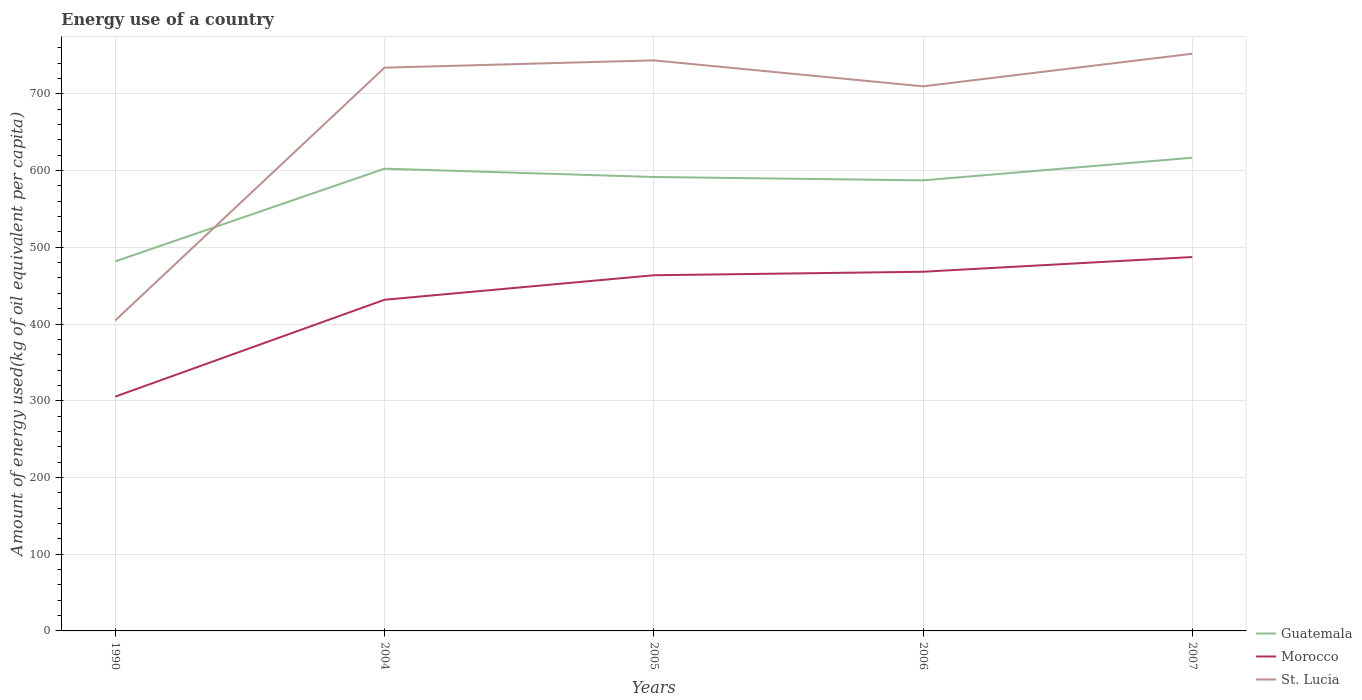How many different coloured lines are there?
Give a very brief answer. 3. Across all years, what is the maximum amount of energy used in in St. Lucia?
Your answer should be very brief. 404.69. In which year was the amount of energy used in in St. Lucia maximum?
Provide a short and direct response. 1990. What is the total amount of energy used in in Morocco in the graph?
Keep it short and to the point. -23.75. What is the difference between the highest and the second highest amount of energy used in in Morocco?
Offer a very short reply. 181.91. What is the difference between the highest and the lowest amount of energy used in in Morocco?
Your answer should be compact. 4. How many years are there in the graph?
Ensure brevity in your answer.  5. What is the difference between two consecutive major ticks on the Y-axis?
Your answer should be compact. 100. Does the graph contain any zero values?
Your answer should be very brief. No. What is the title of the graph?
Keep it short and to the point. Energy use of a country. Does "North America" appear as one of the legend labels in the graph?
Your answer should be compact. No. What is the label or title of the Y-axis?
Offer a terse response. Amount of energy used(kg of oil equivalent per capita). What is the Amount of energy used(kg of oil equivalent per capita) of Guatemala in 1990?
Your response must be concise. 481.64. What is the Amount of energy used(kg of oil equivalent per capita) of Morocco in 1990?
Provide a short and direct response. 305.39. What is the Amount of energy used(kg of oil equivalent per capita) of St. Lucia in 1990?
Your answer should be very brief. 404.69. What is the Amount of energy used(kg of oil equivalent per capita) in Guatemala in 2004?
Offer a very short reply. 602.44. What is the Amount of energy used(kg of oil equivalent per capita) of Morocco in 2004?
Ensure brevity in your answer.  431.63. What is the Amount of energy used(kg of oil equivalent per capita) in St. Lucia in 2004?
Offer a very short reply. 734.12. What is the Amount of energy used(kg of oil equivalent per capita) in Guatemala in 2005?
Provide a succinct answer. 591.64. What is the Amount of energy used(kg of oil equivalent per capita) in Morocco in 2005?
Keep it short and to the point. 463.56. What is the Amount of energy used(kg of oil equivalent per capita) in St. Lucia in 2005?
Ensure brevity in your answer.  743.62. What is the Amount of energy used(kg of oil equivalent per capita) in Guatemala in 2006?
Keep it short and to the point. 587.24. What is the Amount of energy used(kg of oil equivalent per capita) in Morocco in 2006?
Offer a terse response. 468.14. What is the Amount of energy used(kg of oil equivalent per capita) in St. Lucia in 2006?
Your answer should be compact. 709.79. What is the Amount of energy used(kg of oil equivalent per capita) in Guatemala in 2007?
Offer a terse response. 616.73. What is the Amount of energy used(kg of oil equivalent per capita) of Morocco in 2007?
Make the answer very short. 487.3. What is the Amount of energy used(kg of oil equivalent per capita) in St. Lucia in 2007?
Your answer should be very brief. 752.3. Across all years, what is the maximum Amount of energy used(kg of oil equivalent per capita) in Guatemala?
Provide a succinct answer. 616.73. Across all years, what is the maximum Amount of energy used(kg of oil equivalent per capita) in Morocco?
Provide a succinct answer. 487.3. Across all years, what is the maximum Amount of energy used(kg of oil equivalent per capita) of St. Lucia?
Your answer should be very brief. 752.3. Across all years, what is the minimum Amount of energy used(kg of oil equivalent per capita) of Guatemala?
Make the answer very short. 481.64. Across all years, what is the minimum Amount of energy used(kg of oil equivalent per capita) in Morocco?
Ensure brevity in your answer.  305.39. Across all years, what is the minimum Amount of energy used(kg of oil equivalent per capita) of St. Lucia?
Provide a succinct answer. 404.69. What is the total Amount of energy used(kg of oil equivalent per capita) of Guatemala in the graph?
Make the answer very short. 2879.69. What is the total Amount of energy used(kg of oil equivalent per capita) of Morocco in the graph?
Ensure brevity in your answer.  2156.02. What is the total Amount of energy used(kg of oil equivalent per capita) in St. Lucia in the graph?
Give a very brief answer. 3344.51. What is the difference between the Amount of energy used(kg of oil equivalent per capita) of Guatemala in 1990 and that in 2004?
Offer a very short reply. -120.8. What is the difference between the Amount of energy used(kg of oil equivalent per capita) in Morocco in 1990 and that in 2004?
Your response must be concise. -126.24. What is the difference between the Amount of energy used(kg of oil equivalent per capita) of St. Lucia in 1990 and that in 2004?
Offer a terse response. -329.43. What is the difference between the Amount of energy used(kg of oil equivalent per capita) of Guatemala in 1990 and that in 2005?
Offer a terse response. -110. What is the difference between the Amount of energy used(kg of oil equivalent per capita) in Morocco in 1990 and that in 2005?
Make the answer very short. -158.17. What is the difference between the Amount of energy used(kg of oil equivalent per capita) in St. Lucia in 1990 and that in 2005?
Make the answer very short. -338.93. What is the difference between the Amount of energy used(kg of oil equivalent per capita) of Guatemala in 1990 and that in 2006?
Your response must be concise. -105.6. What is the difference between the Amount of energy used(kg of oil equivalent per capita) of Morocco in 1990 and that in 2006?
Ensure brevity in your answer.  -162.74. What is the difference between the Amount of energy used(kg of oil equivalent per capita) of St. Lucia in 1990 and that in 2006?
Give a very brief answer. -305.1. What is the difference between the Amount of energy used(kg of oil equivalent per capita) in Guatemala in 1990 and that in 2007?
Keep it short and to the point. -135.09. What is the difference between the Amount of energy used(kg of oil equivalent per capita) in Morocco in 1990 and that in 2007?
Your answer should be compact. -181.91. What is the difference between the Amount of energy used(kg of oil equivalent per capita) of St. Lucia in 1990 and that in 2007?
Offer a very short reply. -347.61. What is the difference between the Amount of energy used(kg of oil equivalent per capita) of Guatemala in 2004 and that in 2005?
Provide a succinct answer. 10.81. What is the difference between the Amount of energy used(kg of oil equivalent per capita) in Morocco in 2004 and that in 2005?
Provide a short and direct response. -31.92. What is the difference between the Amount of energy used(kg of oil equivalent per capita) of St. Lucia in 2004 and that in 2005?
Offer a very short reply. -9.5. What is the difference between the Amount of energy used(kg of oil equivalent per capita) in Guatemala in 2004 and that in 2006?
Your answer should be very brief. 15.21. What is the difference between the Amount of energy used(kg of oil equivalent per capita) of Morocco in 2004 and that in 2006?
Your answer should be compact. -36.5. What is the difference between the Amount of energy used(kg of oil equivalent per capita) of St. Lucia in 2004 and that in 2006?
Keep it short and to the point. 24.33. What is the difference between the Amount of energy used(kg of oil equivalent per capita) of Guatemala in 2004 and that in 2007?
Your answer should be very brief. -14.29. What is the difference between the Amount of energy used(kg of oil equivalent per capita) in Morocco in 2004 and that in 2007?
Your response must be concise. -55.67. What is the difference between the Amount of energy used(kg of oil equivalent per capita) in St. Lucia in 2004 and that in 2007?
Provide a succinct answer. -18.18. What is the difference between the Amount of energy used(kg of oil equivalent per capita) of Guatemala in 2005 and that in 2006?
Offer a very short reply. 4.4. What is the difference between the Amount of energy used(kg of oil equivalent per capita) of Morocco in 2005 and that in 2006?
Ensure brevity in your answer.  -4.58. What is the difference between the Amount of energy used(kg of oil equivalent per capita) in St. Lucia in 2005 and that in 2006?
Your answer should be compact. 33.83. What is the difference between the Amount of energy used(kg of oil equivalent per capita) in Guatemala in 2005 and that in 2007?
Offer a very short reply. -25.1. What is the difference between the Amount of energy used(kg of oil equivalent per capita) in Morocco in 2005 and that in 2007?
Offer a very short reply. -23.75. What is the difference between the Amount of energy used(kg of oil equivalent per capita) in St. Lucia in 2005 and that in 2007?
Your answer should be compact. -8.67. What is the difference between the Amount of energy used(kg of oil equivalent per capita) in Guatemala in 2006 and that in 2007?
Offer a terse response. -29.5. What is the difference between the Amount of energy used(kg of oil equivalent per capita) in Morocco in 2006 and that in 2007?
Keep it short and to the point. -19.17. What is the difference between the Amount of energy used(kg of oil equivalent per capita) of St. Lucia in 2006 and that in 2007?
Keep it short and to the point. -42.51. What is the difference between the Amount of energy used(kg of oil equivalent per capita) of Guatemala in 1990 and the Amount of energy used(kg of oil equivalent per capita) of Morocco in 2004?
Make the answer very short. 50.01. What is the difference between the Amount of energy used(kg of oil equivalent per capita) of Guatemala in 1990 and the Amount of energy used(kg of oil equivalent per capita) of St. Lucia in 2004?
Your response must be concise. -252.48. What is the difference between the Amount of energy used(kg of oil equivalent per capita) of Morocco in 1990 and the Amount of energy used(kg of oil equivalent per capita) of St. Lucia in 2004?
Make the answer very short. -428.72. What is the difference between the Amount of energy used(kg of oil equivalent per capita) of Guatemala in 1990 and the Amount of energy used(kg of oil equivalent per capita) of Morocco in 2005?
Give a very brief answer. 18.08. What is the difference between the Amount of energy used(kg of oil equivalent per capita) of Guatemala in 1990 and the Amount of energy used(kg of oil equivalent per capita) of St. Lucia in 2005?
Keep it short and to the point. -261.98. What is the difference between the Amount of energy used(kg of oil equivalent per capita) of Morocco in 1990 and the Amount of energy used(kg of oil equivalent per capita) of St. Lucia in 2005?
Make the answer very short. -438.23. What is the difference between the Amount of energy used(kg of oil equivalent per capita) of Guatemala in 1990 and the Amount of energy used(kg of oil equivalent per capita) of Morocco in 2006?
Offer a terse response. 13.5. What is the difference between the Amount of energy used(kg of oil equivalent per capita) in Guatemala in 1990 and the Amount of energy used(kg of oil equivalent per capita) in St. Lucia in 2006?
Make the answer very short. -228.15. What is the difference between the Amount of energy used(kg of oil equivalent per capita) in Morocco in 1990 and the Amount of energy used(kg of oil equivalent per capita) in St. Lucia in 2006?
Give a very brief answer. -404.4. What is the difference between the Amount of energy used(kg of oil equivalent per capita) of Guatemala in 1990 and the Amount of energy used(kg of oil equivalent per capita) of Morocco in 2007?
Your answer should be very brief. -5.66. What is the difference between the Amount of energy used(kg of oil equivalent per capita) in Guatemala in 1990 and the Amount of energy used(kg of oil equivalent per capita) in St. Lucia in 2007?
Provide a short and direct response. -270.65. What is the difference between the Amount of energy used(kg of oil equivalent per capita) of Morocco in 1990 and the Amount of energy used(kg of oil equivalent per capita) of St. Lucia in 2007?
Keep it short and to the point. -446.9. What is the difference between the Amount of energy used(kg of oil equivalent per capita) of Guatemala in 2004 and the Amount of energy used(kg of oil equivalent per capita) of Morocco in 2005?
Offer a very short reply. 138.89. What is the difference between the Amount of energy used(kg of oil equivalent per capita) of Guatemala in 2004 and the Amount of energy used(kg of oil equivalent per capita) of St. Lucia in 2005?
Offer a very short reply. -141.18. What is the difference between the Amount of energy used(kg of oil equivalent per capita) of Morocco in 2004 and the Amount of energy used(kg of oil equivalent per capita) of St. Lucia in 2005?
Keep it short and to the point. -311.99. What is the difference between the Amount of energy used(kg of oil equivalent per capita) of Guatemala in 2004 and the Amount of energy used(kg of oil equivalent per capita) of Morocco in 2006?
Ensure brevity in your answer.  134.31. What is the difference between the Amount of energy used(kg of oil equivalent per capita) in Guatemala in 2004 and the Amount of energy used(kg of oil equivalent per capita) in St. Lucia in 2006?
Provide a succinct answer. -107.34. What is the difference between the Amount of energy used(kg of oil equivalent per capita) of Morocco in 2004 and the Amount of energy used(kg of oil equivalent per capita) of St. Lucia in 2006?
Provide a short and direct response. -278.15. What is the difference between the Amount of energy used(kg of oil equivalent per capita) in Guatemala in 2004 and the Amount of energy used(kg of oil equivalent per capita) in Morocco in 2007?
Give a very brief answer. 115.14. What is the difference between the Amount of energy used(kg of oil equivalent per capita) in Guatemala in 2004 and the Amount of energy used(kg of oil equivalent per capita) in St. Lucia in 2007?
Offer a very short reply. -149.85. What is the difference between the Amount of energy used(kg of oil equivalent per capita) in Morocco in 2004 and the Amount of energy used(kg of oil equivalent per capita) in St. Lucia in 2007?
Provide a short and direct response. -320.66. What is the difference between the Amount of energy used(kg of oil equivalent per capita) of Guatemala in 2005 and the Amount of energy used(kg of oil equivalent per capita) of Morocco in 2006?
Provide a short and direct response. 123.5. What is the difference between the Amount of energy used(kg of oil equivalent per capita) of Guatemala in 2005 and the Amount of energy used(kg of oil equivalent per capita) of St. Lucia in 2006?
Keep it short and to the point. -118.15. What is the difference between the Amount of energy used(kg of oil equivalent per capita) in Morocco in 2005 and the Amount of energy used(kg of oil equivalent per capita) in St. Lucia in 2006?
Your answer should be compact. -246.23. What is the difference between the Amount of energy used(kg of oil equivalent per capita) in Guatemala in 2005 and the Amount of energy used(kg of oil equivalent per capita) in Morocco in 2007?
Ensure brevity in your answer.  104.33. What is the difference between the Amount of energy used(kg of oil equivalent per capita) in Guatemala in 2005 and the Amount of energy used(kg of oil equivalent per capita) in St. Lucia in 2007?
Give a very brief answer. -160.66. What is the difference between the Amount of energy used(kg of oil equivalent per capita) of Morocco in 2005 and the Amount of energy used(kg of oil equivalent per capita) of St. Lucia in 2007?
Your response must be concise. -288.74. What is the difference between the Amount of energy used(kg of oil equivalent per capita) of Guatemala in 2006 and the Amount of energy used(kg of oil equivalent per capita) of Morocco in 2007?
Provide a succinct answer. 99.93. What is the difference between the Amount of energy used(kg of oil equivalent per capita) in Guatemala in 2006 and the Amount of energy used(kg of oil equivalent per capita) in St. Lucia in 2007?
Offer a terse response. -165.06. What is the difference between the Amount of energy used(kg of oil equivalent per capita) in Morocco in 2006 and the Amount of energy used(kg of oil equivalent per capita) in St. Lucia in 2007?
Provide a succinct answer. -284.16. What is the average Amount of energy used(kg of oil equivalent per capita) in Guatemala per year?
Make the answer very short. 575.94. What is the average Amount of energy used(kg of oil equivalent per capita) in Morocco per year?
Provide a short and direct response. 431.2. What is the average Amount of energy used(kg of oil equivalent per capita) of St. Lucia per year?
Your answer should be compact. 668.9. In the year 1990, what is the difference between the Amount of energy used(kg of oil equivalent per capita) in Guatemala and Amount of energy used(kg of oil equivalent per capita) in Morocco?
Your answer should be very brief. 176.25. In the year 1990, what is the difference between the Amount of energy used(kg of oil equivalent per capita) of Guatemala and Amount of energy used(kg of oil equivalent per capita) of St. Lucia?
Your response must be concise. 76.95. In the year 1990, what is the difference between the Amount of energy used(kg of oil equivalent per capita) of Morocco and Amount of energy used(kg of oil equivalent per capita) of St. Lucia?
Ensure brevity in your answer.  -99.3. In the year 2004, what is the difference between the Amount of energy used(kg of oil equivalent per capita) in Guatemala and Amount of energy used(kg of oil equivalent per capita) in Morocco?
Offer a terse response. 170.81. In the year 2004, what is the difference between the Amount of energy used(kg of oil equivalent per capita) of Guatemala and Amount of energy used(kg of oil equivalent per capita) of St. Lucia?
Offer a terse response. -131.67. In the year 2004, what is the difference between the Amount of energy used(kg of oil equivalent per capita) in Morocco and Amount of energy used(kg of oil equivalent per capita) in St. Lucia?
Ensure brevity in your answer.  -302.48. In the year 2005, what is the difference between the Amount of energy used(kg of oil equivalent per capita) of Guatemala and Amount of energy used(kg of oil equivalent per capita) of Morocco?
Keep it short and to the point. 128.08. In the year 2005, what is the difference between the Amount of energy used(kg of oil equivalent per capita) in Guatemala and Amount of energy used(kg of oil equivalent per capita) in St. Lucia?
Offer a very short reply. -151.98. In the year 2005, what is the difference between the Amount of energy used(kg of oil equivalent per capita) of Morocco and Amount of energy used(kg of oil equivalent per capita) of St. Lucia?
Keep it short and to the point. -280.06. In the year 2006, what is the difference between the Amount of energy used(kg of oil equivalent per capita) of Guatemala and Amount of energy used(kg of oil equivalent per capita) of Morocco?
Offer a terse response. 119.1. In the year 2006, what is the difference between the Amount of energy used(kg of oil equivalent per capita) in Guatemala and Amount of energy used(kg of oil equivalent per capita) in St. Lucia?
Provide a succinct answer. -122.55. In the year 2006, what is the difference between the Amount of energy used(kg of oil equivalent per capita) in Morocco and Amount of energy used(kg of oil equivalent per capita) in St. Lucia?
Your response must be concise. -241.65. In the year 2007, what is the difference between the Amount of energy used(kg of oil equivalent per capita) in Guatemala and Amount of energy used(kg of oil equivalent per capita) in Morocco?
Offer a terse response. 129.43. In the year 2007, what is the difference between the Amount of energy used(kg of oil equivalent per capita) in Guatemala and Amount of energy used(kg of oil equivalent per capita) in St. Lucia?
Your answer should be very brief. -135.56. In the year 2007, what is the difference between the Amount of energy used(kg of oil equivalent per capita) of Morocco and Amount of energy used(kg of oil equivalent per capita) of St. Lucia?
Offer a terse response. -264.99. What is the ratio of the Amount of energy used(kg of oil equivalent per capita) in Guatemala in 1990 to that in 2004?
Offer a terse response. 0.8. What is the ratio of the Amount of energy used(kg of oil equivalent per capita) in Morocco in 1990 to that in 2004?
Make the answer very short. 0.71. What is the ratio of the Amount of energy used(kg of oil equivalent per capita) in St. Lucia in 1990 to that in 2004?
Your response must be concise. 0.55. What is the ratio of the Amount of energy used(kg of oil equivalent per capita) of Guatemala in 1990 to that in 2005?
Your response must be concise. 0.81. What is the ratio of the Amount of energy used(kg of oil equivalent per capita) in Morocco in 1990 to that in 2005?
Give a very brief answer. 0.66. What is the ratio of the Amount of energy used(kg of oil equivalent per capita) in St. Lucia in 1990 to that in 2005?
Your answer should be compact. 0.54. What is the ratio of the Amount of energy used(kg of oil equivalent per capita) in Guatemala in 1990 to that in 2006?
Offer a very short reply. 0.82. What is the ratio of the Amount of energy used(kg of oil equivalent per capita) of Morocco in 1990 to that in 2006?
Provide a short and direct response. 0.65. What is the ratio of the Amount of energy used(kg of oil equivalent per capita) of St. Lucia in 1990 to that in 2006?
Make the answer very short. 0.57. What is the ratio of the Amount of energy used(kg of oil equivalent per capita) of Guatemala in 1990 to that in 2007?
Your response must be concise. 0.78. What is the ratio of the Amount of energy used(kg of oil equivalent per capita) of Morocco in 1990 to that in 2007?
Provide a short and direct response. 0.63. What is the ratio of the Amount of energy used(kg of oil equivalent per capita) of St. Lucia in 1990 to that in 2007?
Keep it short and to the point. 0.54. What is the ratio of the Amount of energy used(kg of oil equivalent per capita) in Guatemala in 2004 to that in 2005?
Provide a short and direct response. 1.02. What is the ratio of the Amount of energy used(kg of oil equivalent per capita) in Morocco in 2004 to that in 2005?
Ensure brevity in your answer.  0.93. What is the ratio of the Amount of energy used(kg of oil equivalent per capita) in St. Lucia in 2004 to that in 2005?
Your answer should be very brief. 0.99. What is the ratio of the Amount of energy used(kg of oil equivalent per capita) in Guatemala in 2004 to that in 2006?
Provide a succinct answer. 1.03. What is the ratio of the Amount of energy used(kg of oil equivalent per capita) in Morocco in 2004 to that in 2006?
Offer a terse response. 0.92. What is the ratio of the Amount of energy used(kg of oil equivalent per capita) in St. Lucia in 2004 to that in 2006?
Ensure brevity in your answer.  1.03. What is the ratio of the Amount of energy used(kg of oil equivalent per capita) of Guatemala in 2004 to that in 2007?
Ensure brevity in your answer.  0.98. What is the ratio of the Amount of energy used(kg of oil equivalent per capita) in Morocco in 2004 to that in 2007?
Your response must be concise. 0.89. What is the ratio of the Amount of energy used(kg of oil equivalent per capita) of St. Lucia in 2004 to that in 2007?
Ensure brevity in your answer.  0.98. What is the ratio of the Amount of energy used(kg of oil equivalent per capita) in Guatemala in 2005 to that in 2006?
Offer a terse response. 1.01. What is the ratio of the Amount of energy used(kg of oil equivalent per capita) in Morocco in 2005 to that in 2006?
Offer a very short reply. 0.99. What is the ratio of the Amount of energy used(kg of oil equivalent per capita) of St. Lucia in 2005 to that in 2006?
Give a very brief answer. 1.05. What is the ratio of the Amount of energy used(kg of oil equivalent per capita) of Guatemala in 2005 to that in 2007?
Make the answer very short. 0.96. What is the ratio of the Amount of energy used(kg of oil equivalent per capita) of Morocco in 2005 to that in 2007?
Make the answer very short. 0.95. What is the ratio of the Amount of energy used(kg of oil equivalent per capita) in St. Lucia in 2005 to that in 2007?
Your response must be concise. 0.99. What is the ratio of the Amount of energy used(kg of oil equivalent per capita) in Guatemala in 2006 to that in 2007?
Your answer should be compact. 0.95. What is the ratio of the Amount of energy used(kg of oil equivalent per capita) of Morocco in 2006 to that in 2007?
Offer a very short reply. 0.96. What is the ratio of the Amount of energy used(kg of oil equivalent per capita) of St. Lucia in 2006 to that in 2007?
Keep it short and to the point. 0.94. What is the difference between the highest and the second highest Amount of energy used(kg of oil equivalent per capita) of Guatemala?
Keep it short and to the point. 14.29. What is the difference between the highest and the second highest Amount of energy used(kg of oil equivalent per capita) of Morocco?
Offer a terse response. 19.17. What is the difference between the highest and the second highest Amount of energy used(kg of oil equivalent per capita) of St. Lucia?
Your answer should be very brief. 8.67. What is the difference between the highest and the lowest Amount of energy used(kg of oil equivalent per capita) of Guatemala?
Ensure brevity in your answer.  135.09. What is the difference between the highest and the lowest Amount of energy used(kg of oil equivalent per capita) in Morocco?
Give a very brief answer. 181.91. What is the difference between the highest and the lowest Amount of energy used(kg of oil equivalent per capita) of St. Lucia?
Provide a short and direct response. 347.61. 